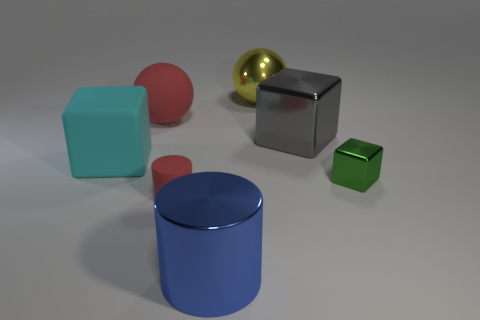Add 2 big cyan matte cubes. How many objects exist? 9 Subtract all metal cubes. How many cubes are left? 1 Subtract 1 cylinders. How many cylinders are left? 1 Subtract all spheres. How many objects are left? 5 Subtract all cyan shiny objects. Subtract all blue objects. How many objects are left? 6 Add 6 cyan cubes. How many cyan cubes are left? 7 Add 4 big red metallic spheres. How many big red metallic spheres exist? 4 Subtract 0 cyan spheres. How many objects are left? 7 